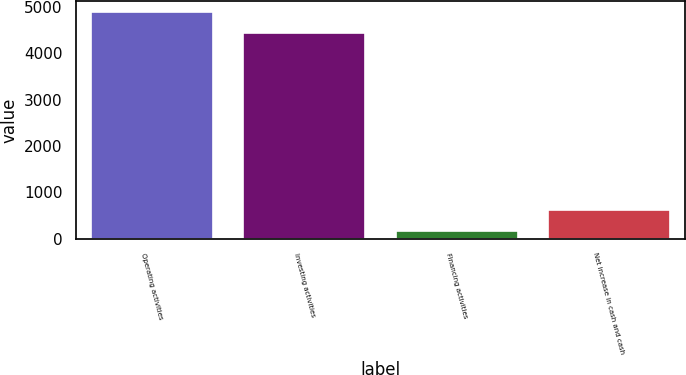Convert chart. <chart><loc_0><loc_0><loc_500><loc_500><bar_chart><fcel>Operating activities<fcel>Investing activities<fcel>Financing activities<fcel>Net increase in cash and cash<nl><fcel>4882.9<fcel>4444<fcel>178<fcel>616.9<nl></chart> 